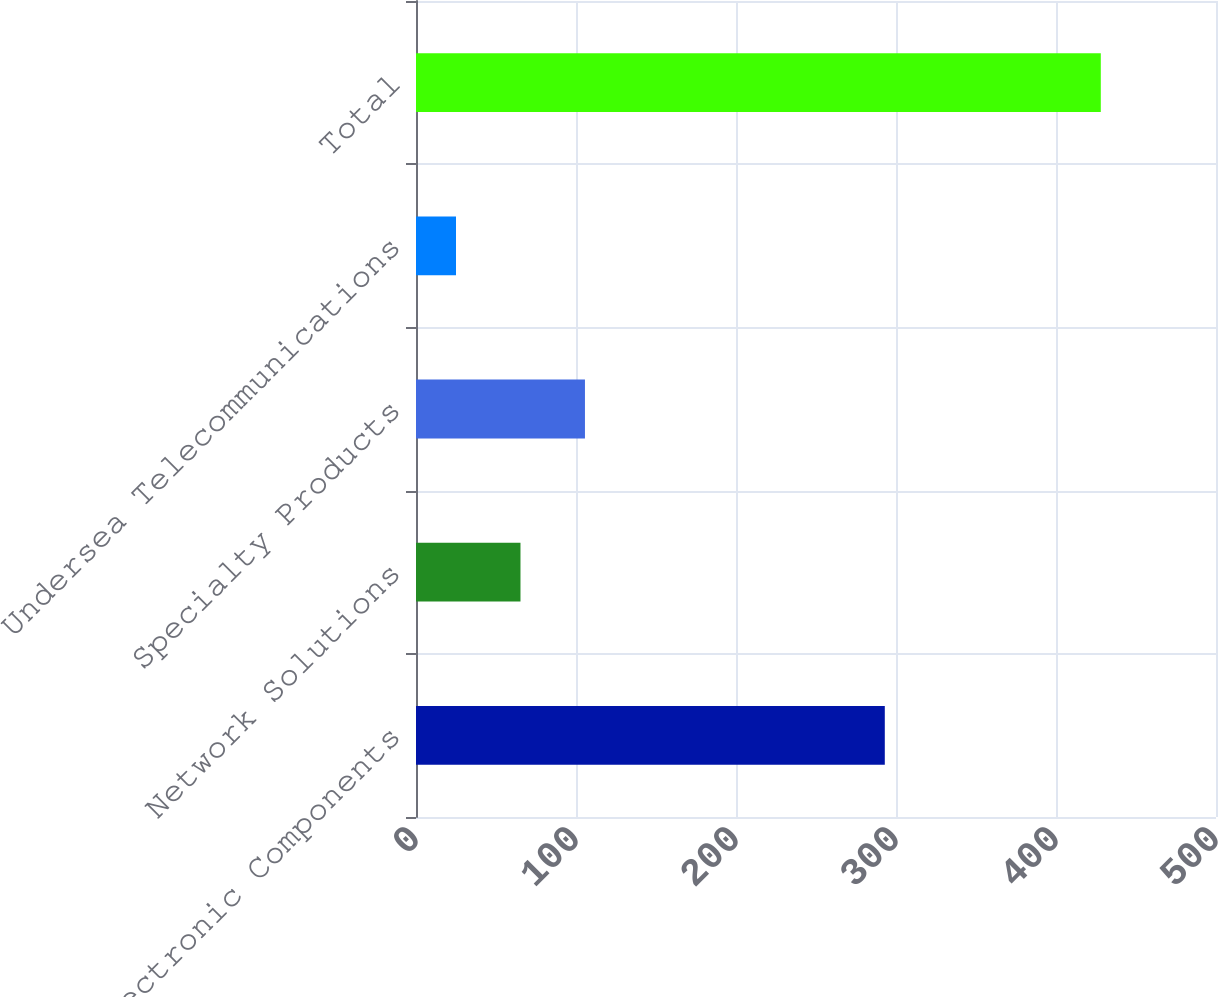<chart> <loc_0><loc_0><loc_500><loc_500><bar_chart><fcel>Electronic Components<fcel>Network Solutions<fcel>Specialty Products<fcel>Undersea Telecommunications<fcel>Total<nl><fcel>293<fcel>65.3<fcel>105.6<fcel>25<fcel>428<nl></chart> 